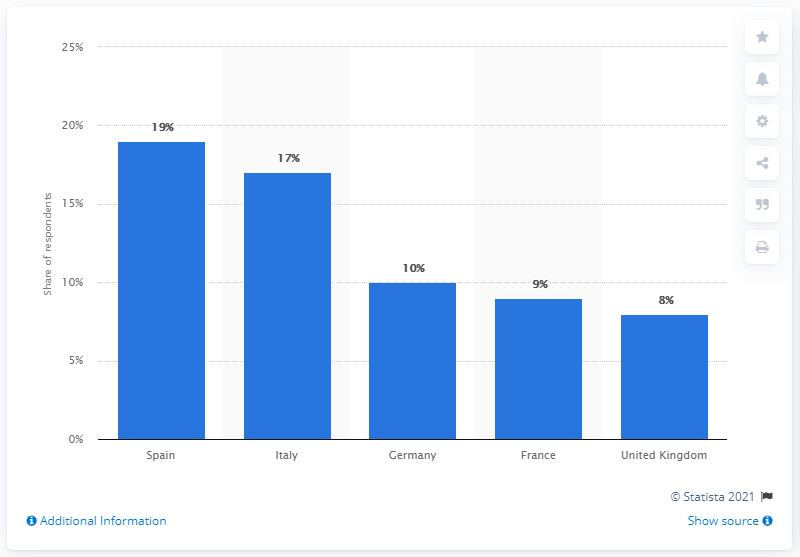List a handful of essential elements in this visual. Italy had the second-highest share of smokers. Spain had the largest share of respondents who now smoke more out of all the European countries surveyed. 